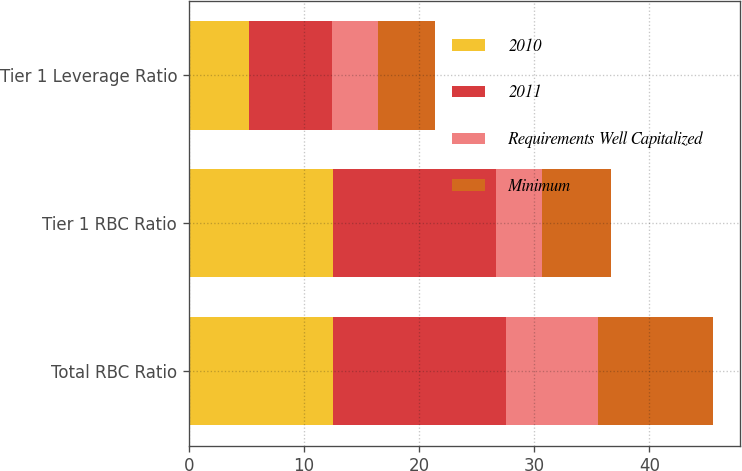Convert chart. <chart><loc_0><loc_0><loc_500><loc_500><stacked_bar_chart><ecel><fcel>Total RBC Ratio<fcel>Tier 1 RBC Ratio<fcel>Tier 1 Leverage Ratio<nl><fcel>2010<fcel>12.55<fcel>12.54<fcel>5.27<nl><fcel>2011<fcel>15<fcel>14.16<fcel>7.14<nl><fcel>Requirements Well Capitalized<fcel>8<fcel>4<fcel>4<nl><fcel>Minimum<fcel>10<fcel>6<fcel>5<nl></chart> 